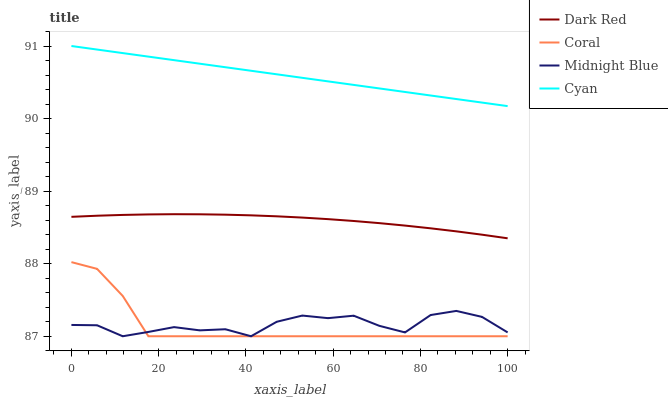Does Coral have the minimum area under the curve?
Answer yes or no. Yes. Does Cyan have the maximum area under the curve?
Answer yes or no. Yes. Does Midnight Blue have the minimum area under the curve?
Answer yes or no. No. Does Midnight Blue have the maximum area under the curve?
Answer yes or no. No. Is Cyan the smoothest?
Answer yes or no. Yes. Is Midnight Blue the roughest?
Answer yes or no. Yes. Is Coral the smoothest?
Answer yes or no. No. Is Coral the roughest?
Answer yes or no. No. Does Coral have the lowest value?
Answer yes or no. Yes. Does Cyan have the lowest value?
Answer yes or no. No. Does Cyan have the highest value?
Answer yes or no. Yes. Does Coral have the highest value?
Answer yes or no. No. Is Dark Red less than Cyan?
Answer yes or no. Yes. Is Cyan greater than Dark Red?
Answer yes or no. Yes. Does Midnight Blue intersect Coral?
Answer yes or no. Yes. Is Midnight Blue less than Coral?
Answer yes or no. No. Is Midnight Blue greater than Coral?
Answer yes or no. No. Does Dark Red intersect Cyan?
Answer yes or no. No. 